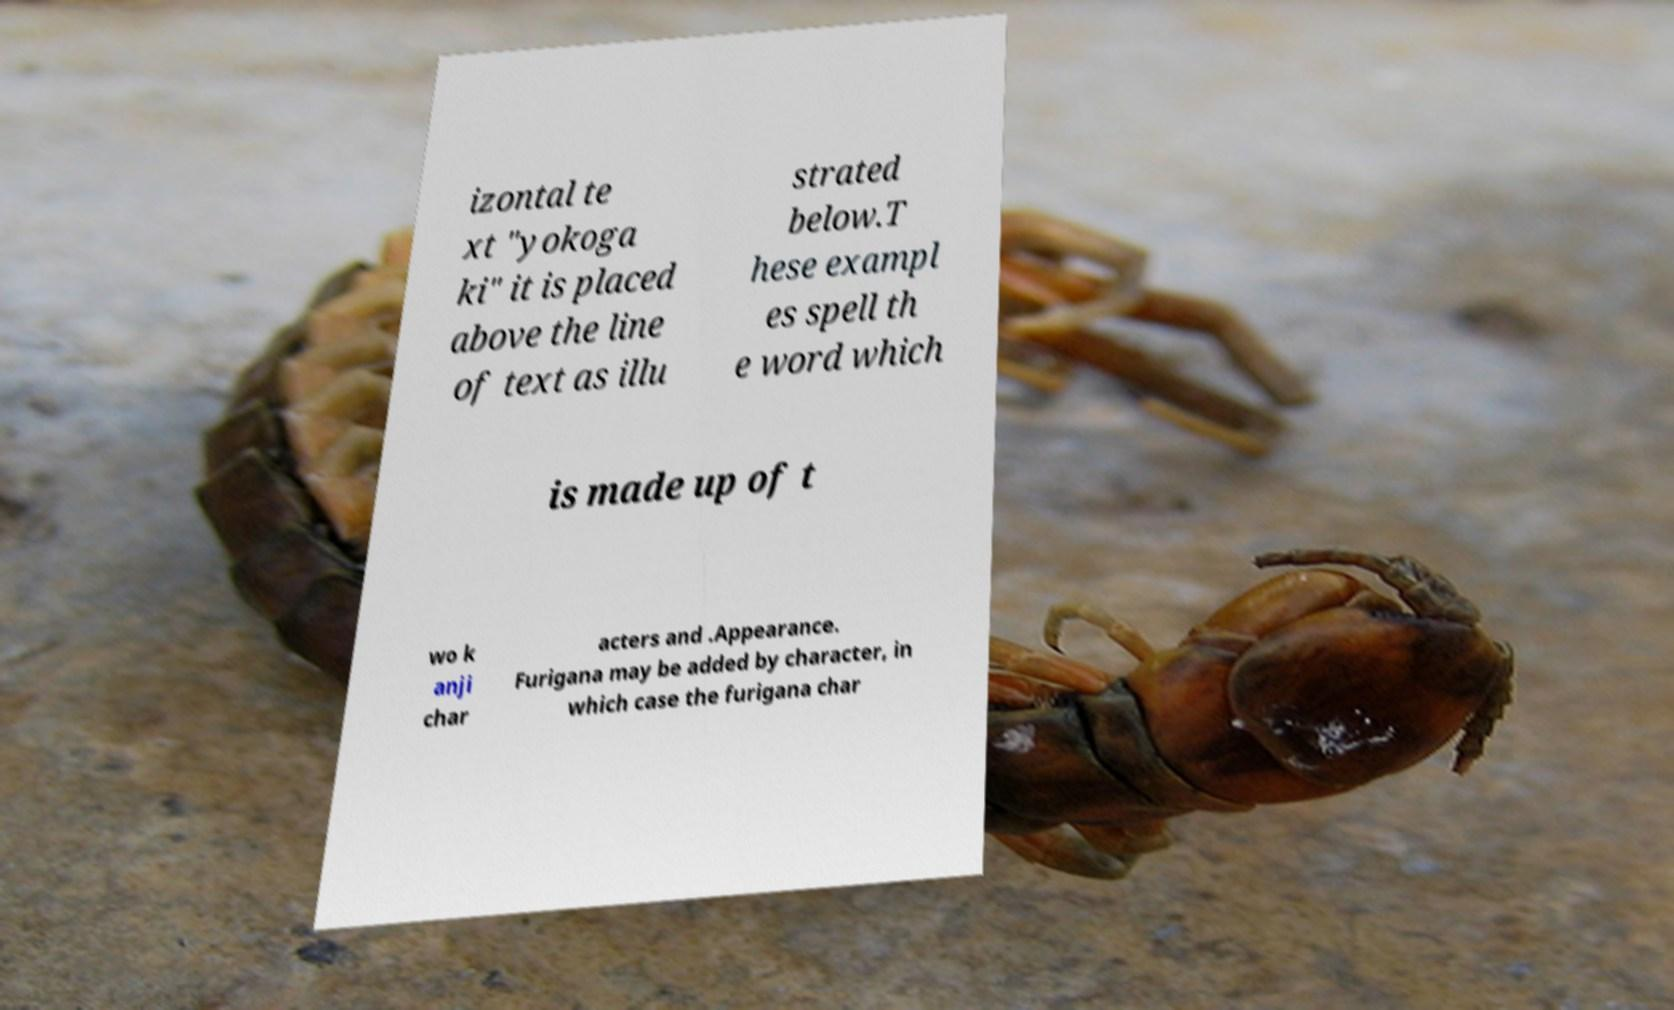What messages or text are displayed in this image? I need them in a readable, typed format. izontal te xt "yokoga ki" it is placed above the line of text as illu strated below.T hese exampl es spell th e word which is made up of t wo k anji char acters and .Appearance. Furigana may be added by character, in which case the furigana char 